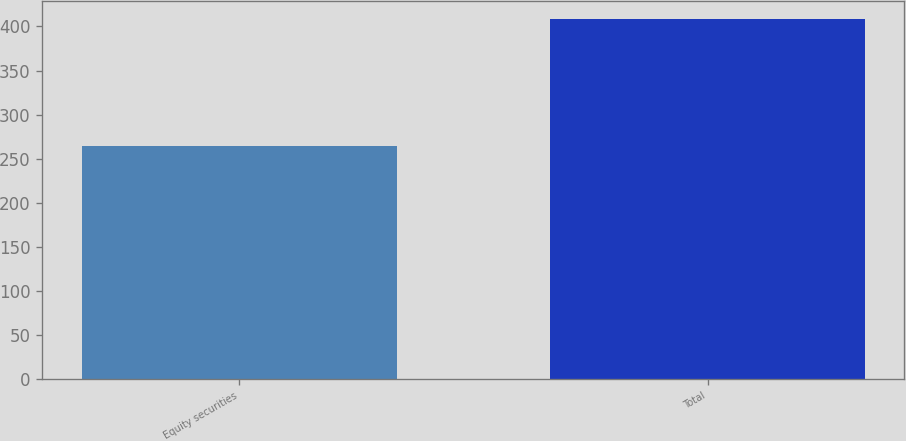Convert chart to OTSL. <chart><loc_0><loc_0><loc_500><loc_500><bar_chart><fcel>Equity securities<fcel>Total<nl><fcel>264<fcel>408<nl></chart> 